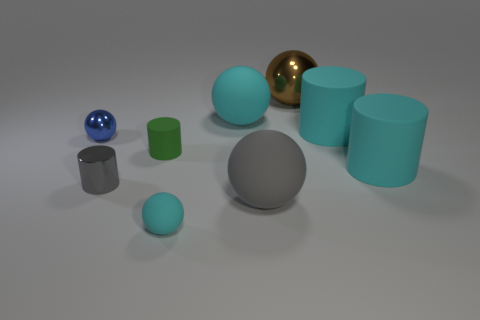Is the material of the ball to the left of the gray cylinder the same as the large cyan sphere?
Offer a very short reply. No. How many tiny objects are blue metallic objects or green rubber cylinders?
Provide a succinct answer. 2. What size is the green cylinder?
Your response must be concise. Small. Does the green thing have the same size as the cylinder that is behind the small green matte cylinder?
Make the answer very short. No. How many brown things are matte spheres or big shiny balls?
Your answer should be very brief. 1. What number of big cyan cubes are there?
Your answer should be compact. 0. There is a green thing behind the gray sphere; what size is it?
Your response must be concise. Small. Do the green cylinder and the blue metal sphere have the same size?
Ensure brevity in your answer.  Yes. How many objects are either small metallic spheres or spheres behind the gray metallic thing?
Offer a very short reply. 3. What material is the tiny blue thing?
Make the answer very short. Metal. 